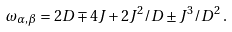<formula> <loc_0><loc_0><loc_500><loc_500>\omega _ { \alpha , \beta } = 2 D \mp 4 J + 2 J ^ { 2 } / D \pm J ^ { 3 } / D ^ { 2 } \, .</formula> 